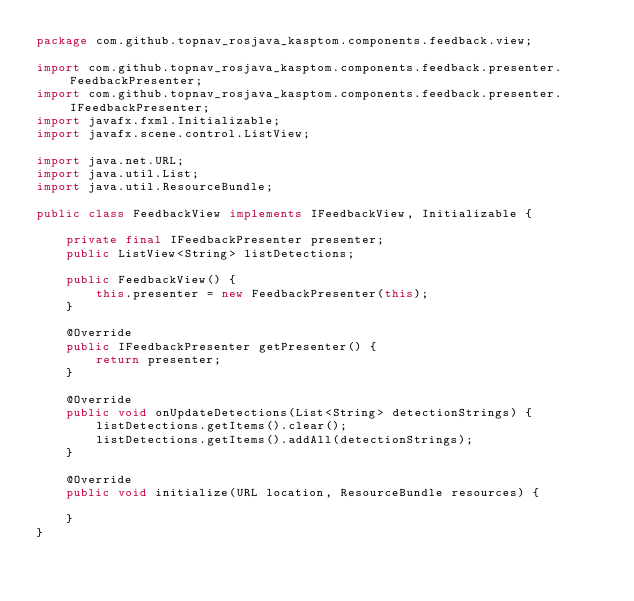Convert code to text. <code><loc_0><loc_0><loc_500><loc_500><_Java_>package com.github.topnav_rosjava_kasptom.components.feedback.view;

import com.github.topnav_rosjava_kasptom.components.feedback.presenter.FeedbackPresenter;
import com.github.topnav_rosjava_kasptom.components.feedback.presenter.IFeedbackPresenter;
import javafx.fxml.Initializable;
import javafx.scene.control.ListView;

import java.net.URL;
import java.util.List;
import java.util.ResourceBundle;

public class FeedbackView implements IFeedbackView, Initializable {

    private final IFeedbackPresenter presenter;
    public ListView<String> listDetections;

    public FeedbackView() {
        this.presenter = new FeedbackPresenter(this);
    }

    @Override
    public IFeedbackPresenter getPresenter() {
        return presenter;
    }

    @Override
    public void onUpdateDetections(List<String> detectionStrings) {
        listDetections.getItems().clear();
        listDetections.getItems().addAll(detectionStrings);
    }

    @Override
    public void initialize(URL location, ResourceBundle resources) {

    }
}
</code> 